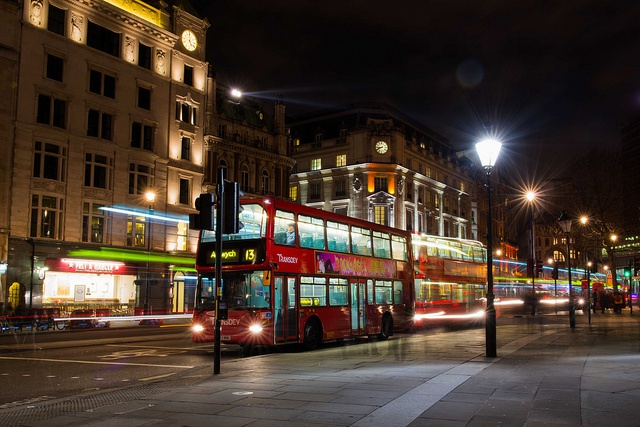Describe the objects in this image and their specific colors. I can see bus in black, maroon, and ivory tones, traffic light in black, gray, white, and blue tones, traffic light in black and gray tones, clock in black, ivory, khaki, olive, and orange tones, and people in black, gray, lightblue, and teal tones in this image. 